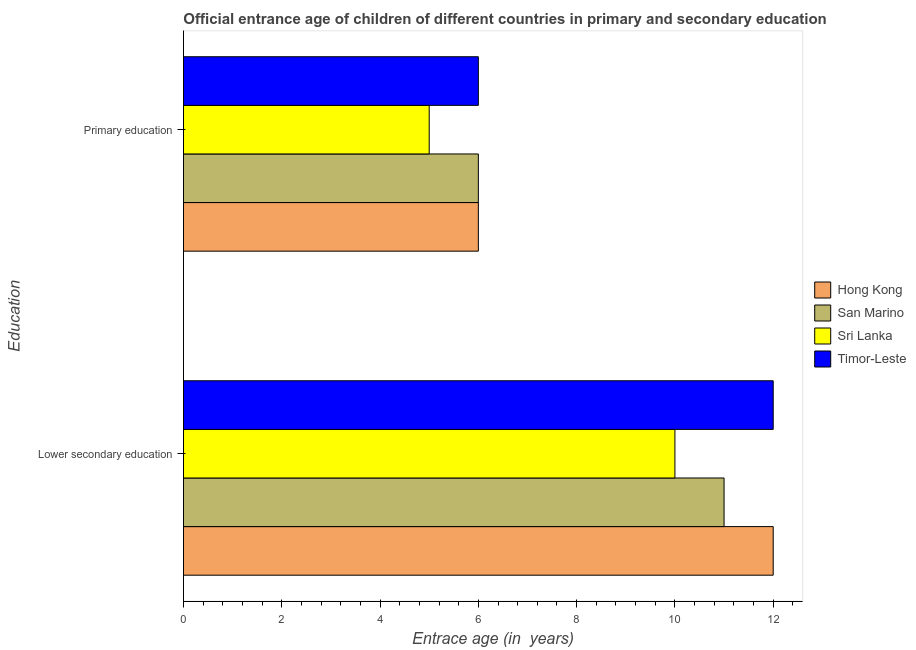Are the number of bars per tick equal to the number of legend labels?
Keep it short and to the point. Yes. How many bars are there on the 1st tick from the top?
Offer a terse response. 4. What is the label of the 2nd group of bars from the top?
Provide a short and direct response. Lower secondary education. What is the entrance age of children in lower secondary education in Sri Lanka?
Keep it short and to the point. 10. Across all countries, what is the maximum entrance age of children in lower secondary education?
Ensure brevity in your answer.  12. Across all countries, what is the minimum entrance age of chiildren in primary education?
Offer a very short reply. 5. In which country was the entrance age of chiildren in primary education maximum?
Your response must be concise. Hong Kong. In which country was the entrance age of children in lower secondary education minimum?
Offer a terse response. Sri Lanka. What is the total entrance age of chiildren in primary education in the graph?
Ensure brevity in your answer.  23. What is the difference between the entrance age of children in lower secondary education in Timor-Leste and that in Hong Kong?
Ensure brevity in your answer.  0. What is the difference between the entrance age of chiildren in primary education in Hong Kong and the entrance age of children in lower secondary education in Timor-Leste?
Offer a terse response. -6. What is the average entrance age of children in lower secondary education per country?
Make the answer very short. 11.25. What is the difference between the entrance age of chiildren in primary education and entrance age of children in lower secondary education in Hong Kong?
Provide a succinct answer. -6. What is the ratio of the entrance age of chiildren in primary education in San Marino to that in Sri Lanka?
Your answer should be compact. 1.2. In how many countries, is the entrance age of chiildren in primary education greater than the average entrance age of chiildren in primary education taken over all countries?
Keep it short and to the point. 3. What does the 3rd bar from the top in Primary education represents?
Ensure brevity in your answer.  San Marino. What does the 2nd bar from the bottom in Primary education represents?
Your answer should be compact. San Marino. How many bars are there?
Give a very brief answer. 8. Are all the bars in the graph horizontal?
Offer a terse response. Yes. How many countries are there in the graph?
Keep it short and to the point. 4. What is the difference between two consecutive major ticks on the X-axis?
Ensure brevity in your answer.  2. Does the graph contain grids?
Offer a terse response. No. Where does the legend appear in the graph?
Offer a terse response. Center right. What is the title of the graph?
Your answer should be compact. Official entrance age of children of different countries in primary and secondary education. What is the label or title of the X-axis?
Provide a short and direct response. Entrace age (in  years). What is the label or title of the Y-axis?
Your answer should be very brief. Education. What is the Entrace age (in  years) of Hong Kong in Lower secondary education?
Your answer should be compact. 12. What is the Entrace age (in  years) of Sri Lanka in Lower secondary education?
Your response must be concise. 10. What is the Entrace age (in  years) of Hong Kong in Primary education?
Ensure brevity in your answer.  6. What is the Entrace age (in  years) in Sri Lanka in Primary education?
Ensure brevity in your answer.  5. Across all Education, what is the maximum Entrace age (in  years) in Timor-Leste?
Provide a succinct answer. 12. Across all Education, what is the minimum Entrace age (in  years) in Hong Kong?
Your answer should be very brief. 6. Across all Education, what is the minimum Entrace age (in  years) in San Marino?
Your answer should be very brief. 6. Across all Education, what is the minimum Entrace age (in  years) of Timor-Leste?
Ensure brevity in your answer.  6. What is the total Entrace age (in  years) in Hong Kong in the graph?
Your response must be concise. 18. What is the total Entrace age (in  years) in San Marino in the graph?
Your answer should be very brief. 17. What is the total Entrace age (in  years) in Sri Lanka in the graph?
Offer a very short reply. 15. What is the difference between the Entrace age (in  years) in Hong Kong in Lower secondary education and that in Primary education?
Keep it short and to the point. 6. What is the difference between the Entrace age (in  years) in San Marino in Lower secondary education and that in Primary education?
Make the answer very short. 5. What is the difference between the Entrace age (in  years) of Timor-Leste in Lower secondary education and that in Primary education?
Your answer should be very brief. 6. What is the difference between the Entrace age (in  years) in Hong Kong in Lower secondary education and the Entrace age (in  years) in Sri Lanka in Primary education?
Your response must be concise. 7. What is the difference between the Entrace age (in  years) of San Marino in Lower secondary education and the Entrace age (in  years) of Timor-Leste in Primary education?
Keep it short and to the point. 5. What is the difference between the Entrace age (in  years) of Sri Lanka in Lower secondary education and the Entrace age (in  years) of Timor-Leste in Primary education?
Offer a very short reply. 4. What is the average Entrace age (in  years) of San Marino per Education?
Provide a short and direct response. 8.5. What is the average Entrace age (in  years) of Timor-Leste per Education?
Provide a short and direct response. 9. What is the difference between the Entrace age (in  years) in Hong Kong and Entrace age (in  years) in Sri Lanka in Lower secondary education?
Offer a very short reply. 2. What is the difference between the Entrace age (in  years) of Hong Kong and Entrace age (in  years) of Timor-Leste in Lower secondary education?
Make the answer very short. 0. What is the difference between the Entrace age (in  years) in San Marino and Entrace age (in  years) in Sri Lanka in Lower secondary education?
Make the answer very short. 1. What is the difference between the Entrace age (in  years) in San Marino and Entrace age (in  years) in Timor-Leste in Lower secondary education?
Offer a very short reply. -1. What is the difference between the Entrace age (in  years) in Sri Lanka and Entrace age (in  years) in Timor-Leste in Lower secondary education?
Your answer should be compact. -2. What is the difference between the Entrace age (in  years) in Hong Kong and Entrace age (in  years) in San Marino in Primary education?
Offer a very short reply. 0. What is the difference between the Entrace age (in  years) of Hong Kong and Entrace age (in  years) of Sri Lanka in Primary education?
Give a very brief answer. 1. What is the difference between the Entrace age (in  years) in Hong Kong and Entrace age (in  years) in Timor-Leste in Primary education?
Your answer should be very brief. 0. What is the difference between the Entrace age (in  years) in San Marino and Entrace age (in  years) in Sri Lanka in Primary education?
Provide a succinct answer. 1. What is the difference between the Entrace age (in  years) in San Marino and Entrace age (in  years) in Timor-Leste in Primary education?
Your answer should be compact. 0. What is the difference between the Entrace age (in  years) in Sri Lanka and Entrace age (in  years) in Timor-Leste in Primary education?
Make the answer very short. -1. What is the ratio of the Entrace age (in  years) of Hong Kong in Lower secondary education to that in Primary education?
Provide a short and direct response. 2. What is the ratio of the Entrace age (in  years) of San Marino in Lower secondary education to that in Primary education?
Provide a short and direct response. 1.83. What is the difference between the highest and the lowest Entrace age (in  years) in Hong Kong?
Ensure brevity in your answer.  6. What is the difference between the highest and the lowest Entrace age (in  years) in San Marino?
Give a very brief answer. 5. What is the difference between the highest and the lowest Entrace age (in  years) of Timor-Leste?
Your answer should be very brief. 6. 